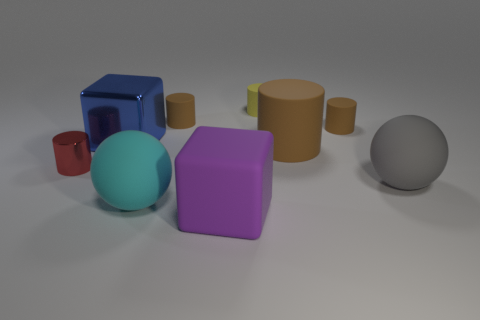Subtract all brown cylinders. How many were subtracted if there are1brown cylinders left? 2 Subtract all green blocks. How many brown cylinders are left? 3 Add 1 large gray things. How many objects exist? 10 Subtract all metallic cylinders. How many cylinders are left? 4 Subtract 2 cylinders. How many cylinders are left? 3 Subtract all red cylinders. How many cylinders are left? 4 Subtract all balls. How many objects are left? 7 Subtract all yellow cylinders. Subtract all green blocks. How many cylinders are left? 4 Subtract 1 cyan balls. How many objects are left? 8 Subtract all red matte cubes. Subtract all cubes. How many objects are left? 7 